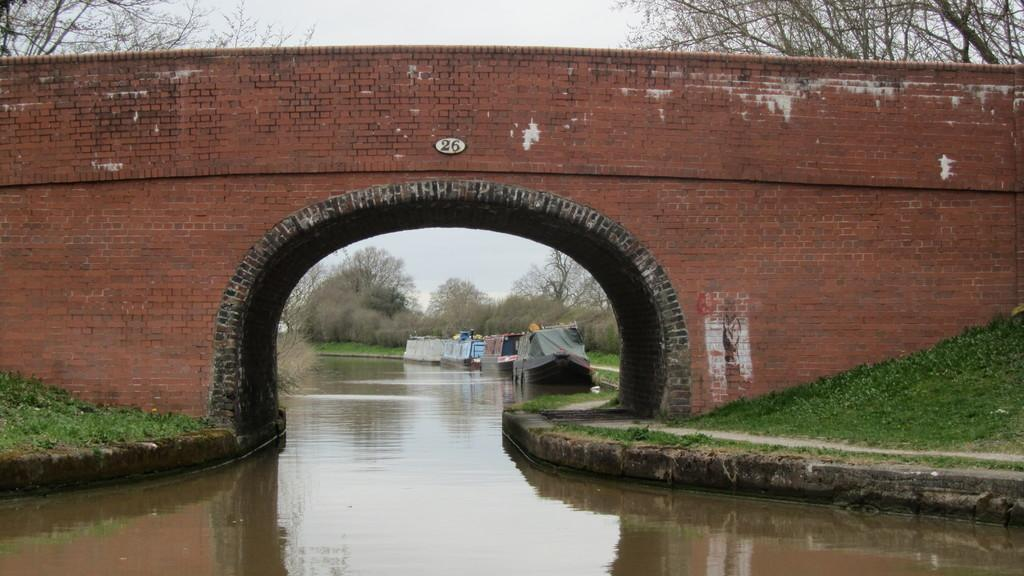What can be seen in the sky in the image? The sky is visible in the image. What type of vegetation is present in the image? There are trees and bushes in the image. What structure can be seen in the image? There is a small bridge in the image. What type of dwelling is present in the image? Houseboats are present in the image. What type of terrain is visible in the image? Grass is visible in the image. What natural feature is present in the image? There is water in the image. Reasoning: Let' Let's think step by step in order to produce the conversation. We start by identifying the main elements of the image, such as the sky, trees, and bushes. Then, we focus on specific structures and dwellings, like the small bridge and houseboats. Finally, we mention the terrain and natural features, such as the grass and water. Each question is designed to elicit a specific detail about the image that is known from the provided facts. Absurd Question/Answer: How does the butter contribute to the landscape in the image? There is no butter present in the image, so it cannot contribute to the landscape. 